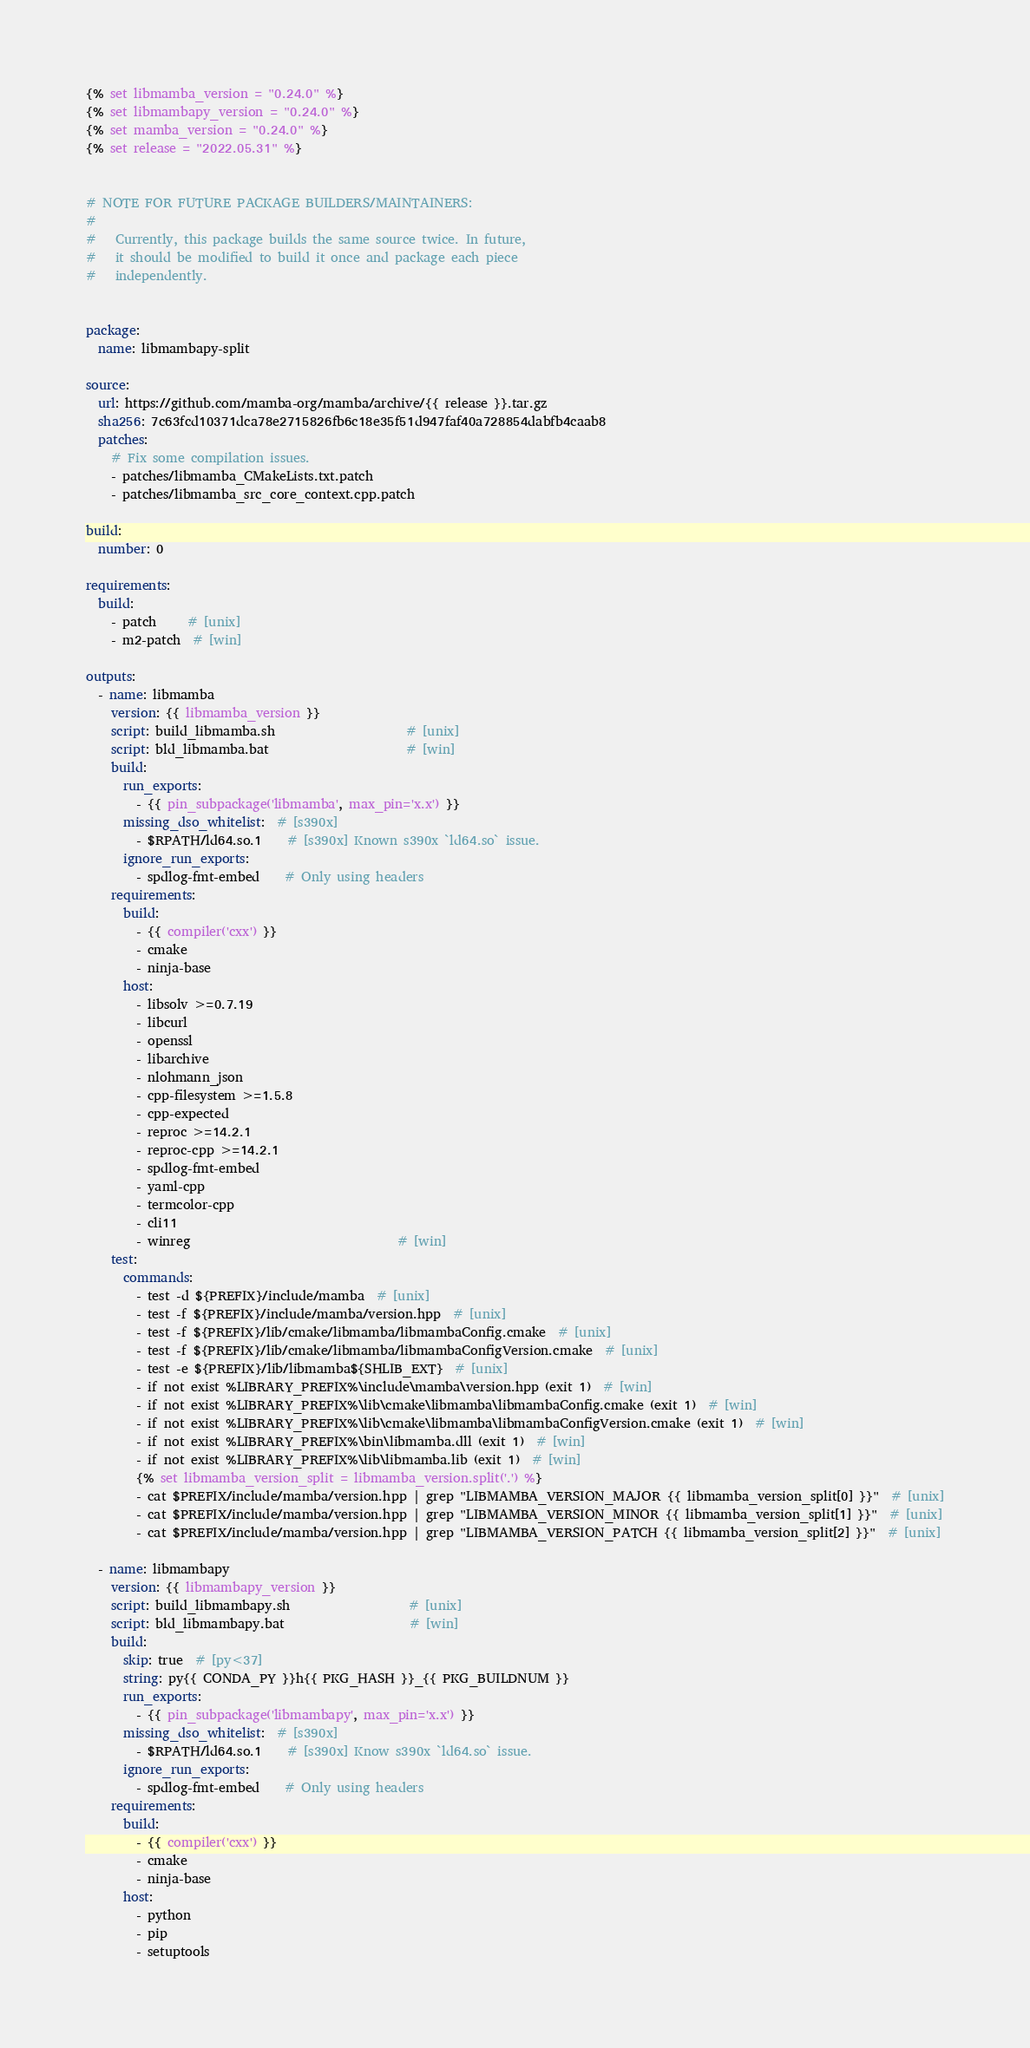<code> <loc_0><loc_0><loc_500><loc_500><_YAML_>{% set libmamba_version = "0.24.0" %}
{% set libmambapy_version = "0.24.0" %}
{% set mamba_version = "0.24.0" %}
{% set release = "2022.05.31" %}


# NOTE FOR FUTURE PACKAGE BUILDERS/MAINTAINERS:
#
#   Currently, this package builds the same source twice. In future,
#   it should be modified to build it once and package each piece
#   independently.


package:
  name: libmambapy-split

source:
  url: https://github.com/mamba-org/mamba/archive/{{ release }}.tar.gz
  sha256: 7c63fcd10371dca78e2715826fb6c18e35f51d947faf40a728854dabfb4caab8
  patches:
    # Fix some compilation issues.
    - patches/libmamba_CMakeLists.txt.patch
    - patches/libmamba_src_core_context.cpp.patch

build:
  number: 0

requirements:
  build:
    - patch     # [unix]
    - m2-patch  # [win]

outputs:
  - name: libmamba
    version: {{ libmamba_version }}
    script: build_libmamba.sh                     # [unix]
    script: bld_libmamba.bat                      # [win]
    build:
      run_exports:
        - {{ pin_subpackage('libmamba', max_pin='x.x') }}
      missing_dso_whitelist:  # [s390x]
        - $RPATH/ld64.so.1    # [s390x] Known s390x `ld64.so` issue.
      ignore_run_exports:
        - spdlog-fmt-embed    # Only using headers
    requirements:
      build:
        - {{ compiler('cxx') }}
        - cmake
        - ninja-base
      host:
        - libsolv >=0.7.19
        - libcurl
        - openssl
        - libarchive
        - nlohmann_json
        - cpp-filesystem >=1.5.8
        - cpp-expected
        - reproc >=14.2.1
        - reproc-cpp >=14.2.1
        - spdlog-fmt-embed
        - yaml-cpp
        - termcolor-cpp
        - cli11
        - winreg                                 # [win]
    test:
      commands:
        - test -d ${PREFIX}/include/mamba  # [unix]
        - test -f ${PREFIX}/include/mamba/version.hpp  # [unix]
        - test -f ${PREFIX}/lib/cmake/libmamba/libmambaConfig.cmake  # [unix]
        - test -f ${PREFIX}/lib/cmake/libmamba/libmambaConfigVersion.cmake  # [unix]
        - test -e ${PREFIX}/lib/libmamba${SHLIB_EXT}  # [unix]
        - if not exist %LIBRARY_PREFIX%\include\mamba\version.hpp (exit 1)  # [win]
        - if not exist %LIBRARY_PREFIX%\lib\cmake\libmamba\libmambaConfig.cmake (exit 1)  # [win]
        - if not exist %LIBRARY_PREFIX%\lib\cmake\libmamba\libmambaConfigVersion.cmake (exit 1)  # [win]
        - if not exist %LIBRARY_PREFIX%\bin\libmamba.dll (exit 1)  # [win]
        - if not exist %LIBRARY_PREFIX%\lib\libmamba.lib (exit 1)  # [win]
        {% set libmamba_version_split = libmamba_version.split('.') %}
        - cat $PREFIX/include/mamba/version.hpp | grep "LIBMAMBA_VERSION_MAJOR {{ libmamba_version_split[0] }}"  # [unix]
        - cat $PREFIX/include/mamba/version.hpp | grep "LIBMAMBA_VERSION_MINOR {{ libmamba_version_split[1] }}"  # [unix]
        - cat $PREFIX/include/mamba/version.hpp | grep "LIBMAMBA_VERSION_PATCH {{ libmamba_version_split[2] }}"  # [unix]

  - name: libmambapy
    version: {{ libmambapy_version }}
    script: build_libmambapy.sh                   # [unix]
    script: bld_libmambapy.bat                    # [win]
    build:
      skip: true  # [py<37]
      string: py{{ CONDA_PY }}h{{ PKG_HASH }}_{{ PKG_BUILDNUM }}
      run_exports:
        - {{ pin_subpackage('libmambapy', max_pin='x.x') }}
      missing_dso_whitelist:  # [s390x]
        - $RPATH/ld64.so.1    # [s390x] Know s390x `ld64.so` issue.
      ignore_run_exports:
        - spdlog-fmt-embed    # Only using headers
    requirements:
      build:
        - {{ compiler('cxx') }}
        - cmake
        - ninja-base
      host:
        - python
        - pip
        - setuptools</code> 